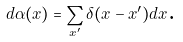<formula> <loc_0><loc_0><loc_500><loc_500>d \alpha ( x ) = \sum _ { x ^ { \prime } } \delta ( x - x ^ { \prime } ) d x \text {.}</formula> 